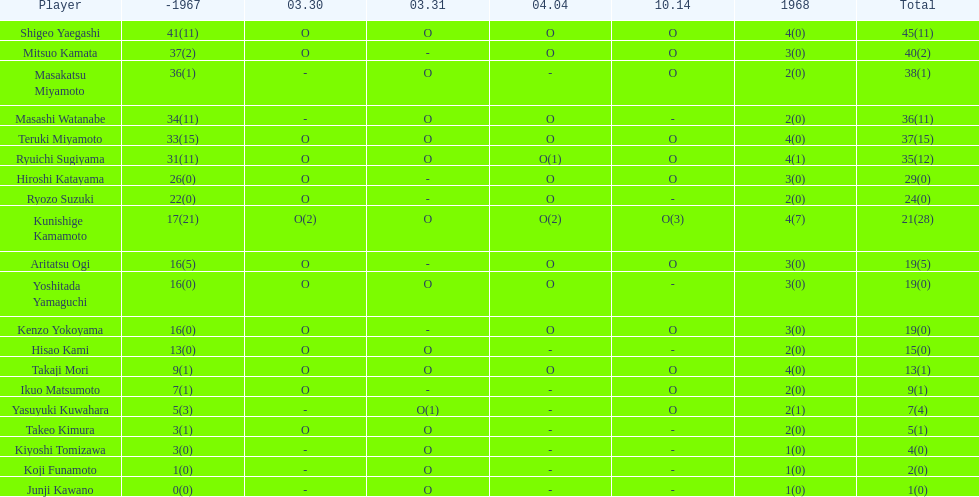Did mitsuo kamata accumulate over 40 overall points? No. 